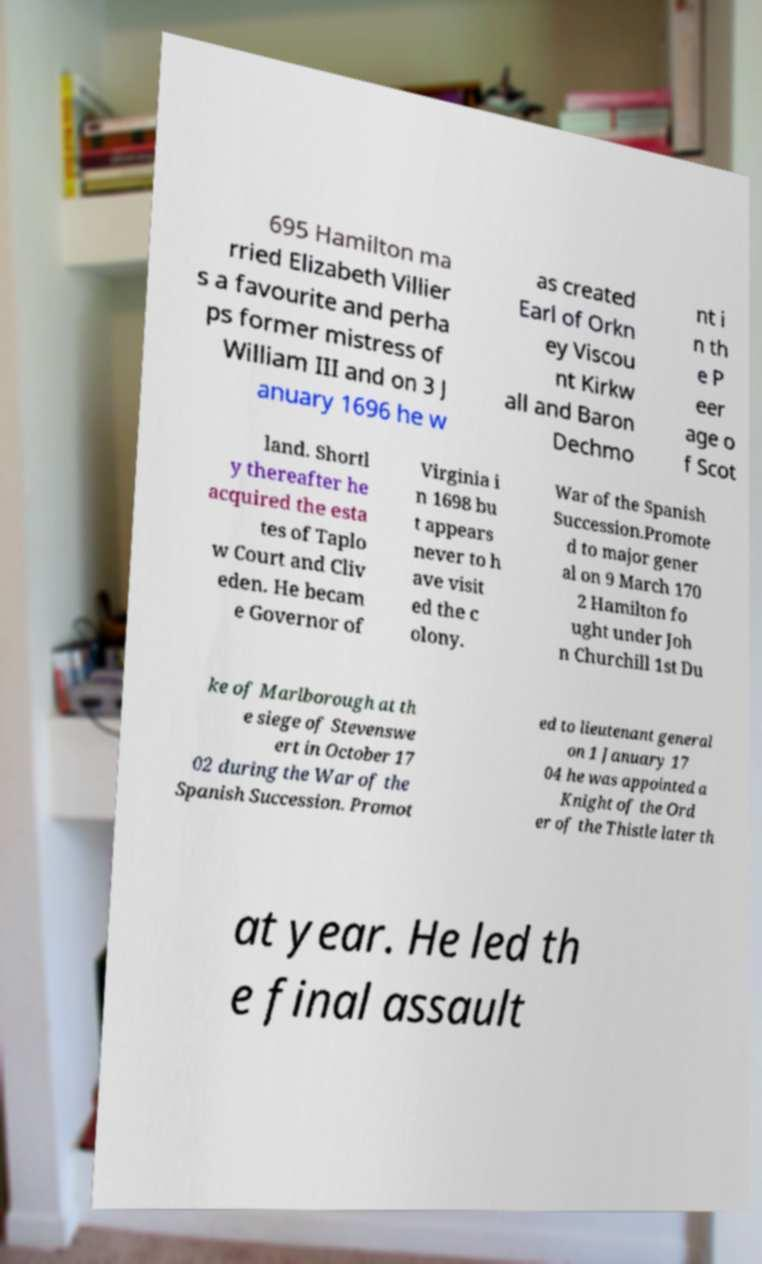Can you accurately transcribe the text from the provided image for me? 695 Hamilton ma rried Elizabeth Villier s a favourite and perha ps former mistress of William III and on 3 J anuary 1696 he w as created Earl of Orkn ey Viscou nt Kirkw all and Baron Dechmo nt i n th e P eer age o f Scot land. Shortl y thereafter he acquired the esta tes of Taplo w Court and Cliv eden. He becam e Governor of Virginia i n 1698 bu t appears never to h ave visit ed the c olony. War of the Spanish Succession.Promote d to major gener al on 9 March 170 2 Hamilton fo ught under Joh n Churchill 1st Du ke of Marlborough at th e siege of Stevenswe ert in October 17 02 during the War of the Spanish Succession. Promot ed to lieutenant general on 1 January 17 04 he was appointed a Knight of the Ord er of the Thistle later th at year. He led th e final assault 